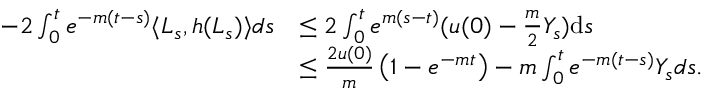Convert formula to latex. <formula><loc_0><loc_0><loc_500><loc_500>\begin{array} { r l } { - 2 \int _ { 0 } ^ { t } e ^ { - m ( t - s ) } \langle L _ { s } , h ( L _ { s } ) \rangle d s } & { \leq 2 \int _ { 0 } ^ { t } e ^ { m ( s - t ) } ( u ( 0 ) - \frac { m } { 2 } Y _ { s } ) d s } \\ & { \leq \frac { 2 u ( 0 ) } { m } \left ( 1 - e ^ { - m t } \right ) - m \int _ { 0 } ^ { t } e ^ { - m ( t - s ) } Y _ { s } d s . } \end{array}</formula> 